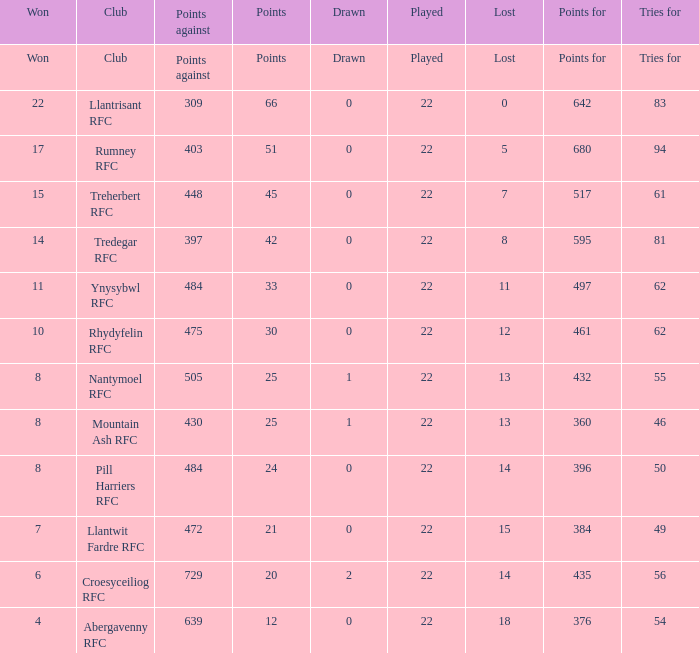Which club lost exactly 7 matches? Treherbert RFC. 